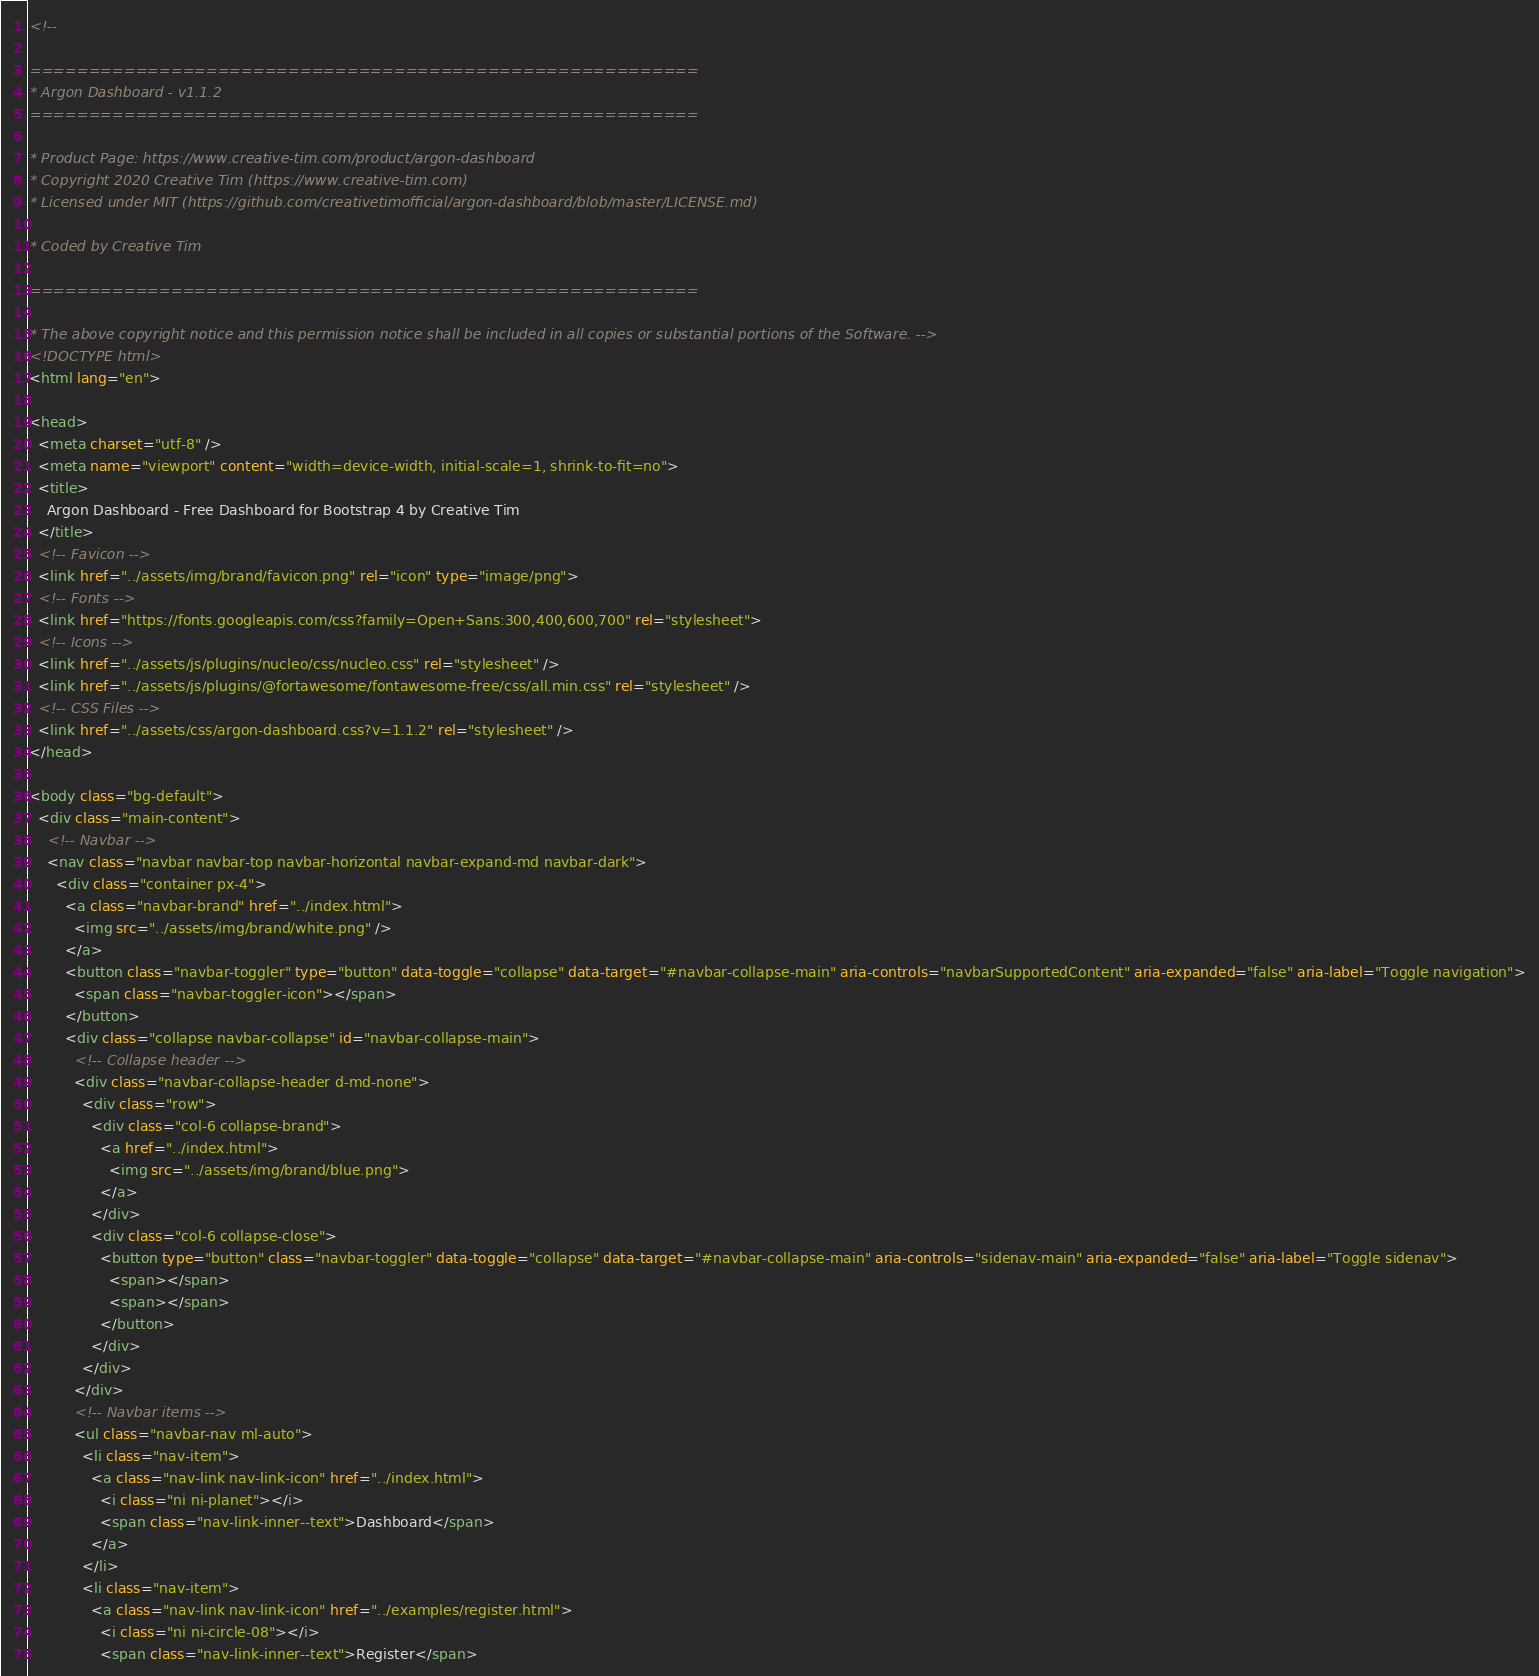Convert code to text. <code><loc_0><loc_0><loc_500><loc_500><_HTML_><!--

=========================================================
* Argon Dashboard - v1.1.2
=========================================================

* Product Page: https://www.creative-tim.com/product/argon-dashboard
* Copyright 2020 Creative Tim (https://www.creative-tim.com)
* Licensed under MIT (https://github.com/creativetimofficial/argon-dashboard/blob/master/LICENSE.md)

* Coded by Creative Tim

=========================================================

* The above copyright notice and this permission notice shall be included in all copies or substantial portions of the Software. -->
<!DOCTYPE html>
<html lang="en">

<head>
  <meta charset="utf-8" />
  <meta name="viewport" content="width=device-width, initial-scale=1, shrink-to-fit=no">
  <title>
    Argon Dashboard - Free Dashboard for Bootstrap 4 by Creative Tim
  </title>
  <!-- Favicon -->
  <link href="../assets/img/brand/favicon.png" rel="icon" type="image/png">
  <!-- Fonts -->
  <link href="https://fonts.googleapis.com/css?family=Open+Sans:300,400,600,700" rel="stylesheet">
  <!-- Icons -->
  <link href="../assets/js/plugins/nucleo/css/nucleo.css" rel="stylesheet" />
  <link href="../assets/js/plugins/@fortawesome/fontawesome-free/css/all.min.css" rel="stylesheet" />
  <!-- CSS Files -->
  <link href="../assets/css/argon-dashboard.css?v=1.1.2" rel="stylesheet" />
</head>

<body class="bg-default">
  <div class="main-content">
    <!-- Navbar -->
    <nav class="navbar navbar-top navbar-horizontal navbar-expand-md navbar-dark">
      <div class="container px-4">
        <a class="navbar-brand" href="../index.html">
          <img src="../assets/img/brand/white.png" />
        </a>
        <button class="navbar-toggler" type="button" data-toggle="collapse" data-target="#navbar-collapse-main" aria-controls="navbarSupportedContent" aria-expanded="false" aria-label="Toggle navigation">
          <span class="navbar-toggler-icon"></span>
        </button>
        <div class="collapse navbar-collapse" id="navbar-collapse-main">
          <!-- Collapse header -->
          <div class="navbar-collapse-header d-md-none">
            <div class="row">
              <div class="col-6 collapse-brand">
                <a href="../index.html">
                  <img src="../assets/img/brand/blue.png">
                </a>
              </div>
              <div class="col-6 collapse-close">
                <button type="button" class="navbar-toggler" data-toggle="collapse" data-target="#navbar-collapse-main" aria-controls="sidenav-main" aria-expanded="false" aria-label="Toggle sidenav">
                  <span></span>
                  <span></span>
                </button>
              </div>
            </div>
          </div>
          <!-- Navbar items -->
          <ul class="navbar-nav ml-auto">
            <li class="nav-item">
              <a class="nav-link nav-link-icon" href="../index.html">
                <i class="ni ni-planet"></i>
                <span class="nav-link-inner--text">Dashboard</span>
              </a>
            </li>
            <li class="nav-item">
              <a class="nav-link nav-link-icon" href="../examples/register.html">
                <i class="ni ni-circle-08"></i>
                <span class="nav-link-inner--text">Register</span></code> 